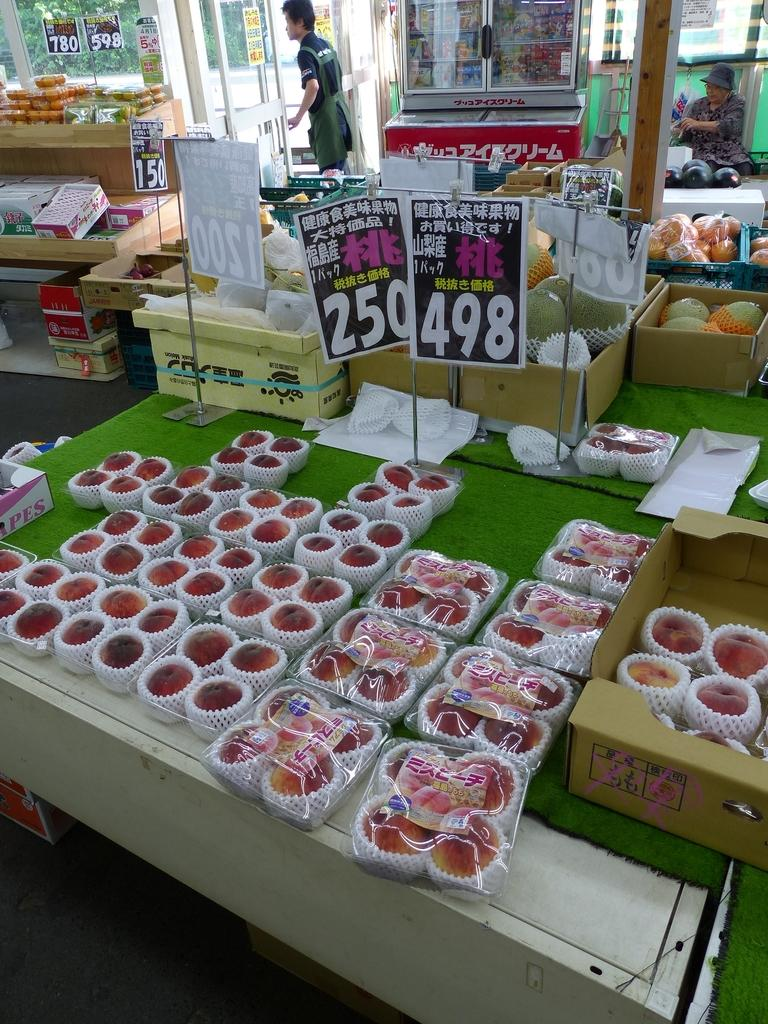<image>
Share a concise interpretation of the image provided. a table full of fruites with a sign above them that says '250' 